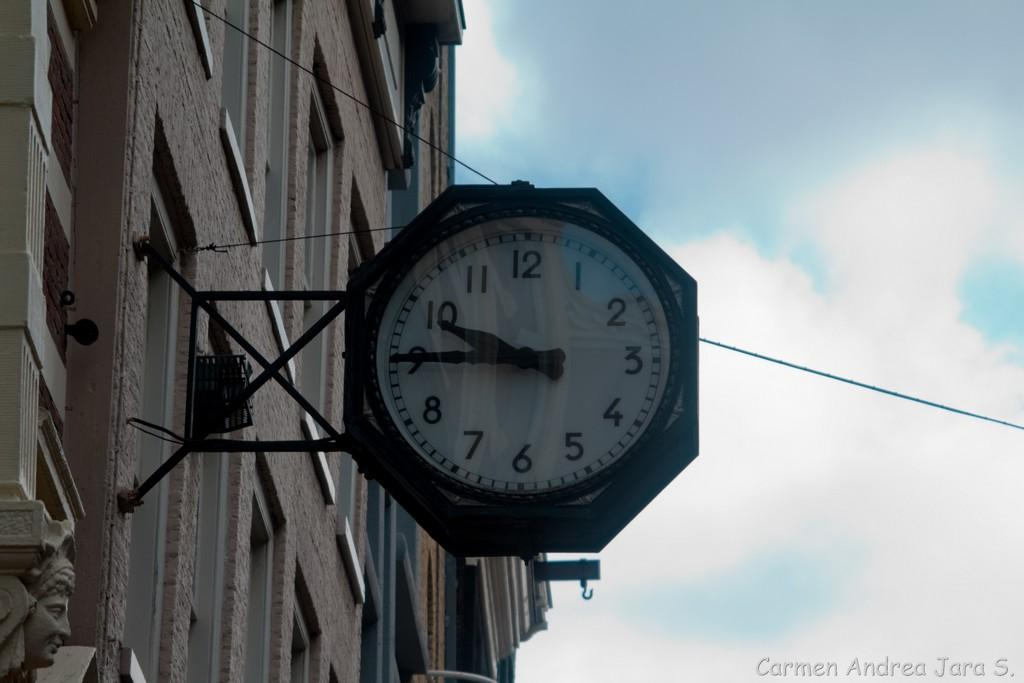<image>
Share a concise interpretation of the image provided. A clock on the outside of a wall and the clock has the number 9 on it. 